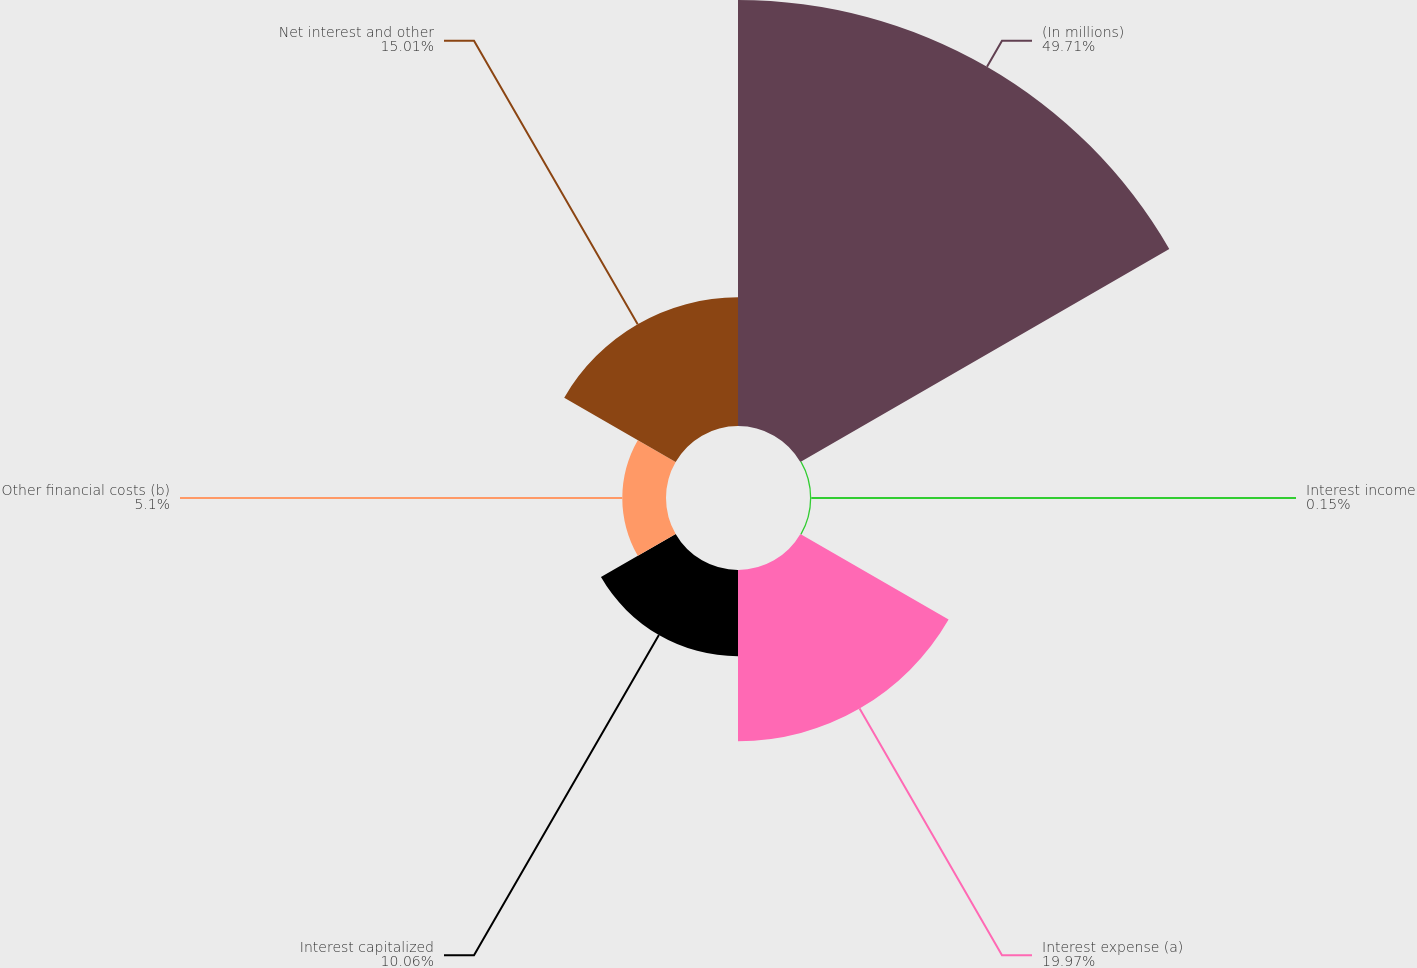Convert chart to OTSL. <chart><loc_0><loc_0><loc_500><loc_500><pie_chart><fcel>(In millions)<fcel>Interest income<fcel>Interest expense (a)<fcel>Interest capitalized<fcel>Other financial costs (b)<fcel>Net interest and other<nl><fcel>49.7%<fcel>0.15%<fcel>19.97%<fcel>10.06%<fcel>5.1%<fcel>15.01%<nl></chart> 